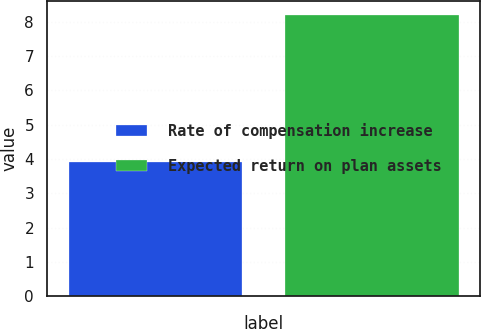Convert chart. <chart><loc_0><loc_0><loc_500><loc_500><bar_chart><fcel>Rate of compensation increase<fcel>Expected return on plan assets<nl><fcel>3.9<fcel>8.2<nl></chart> 